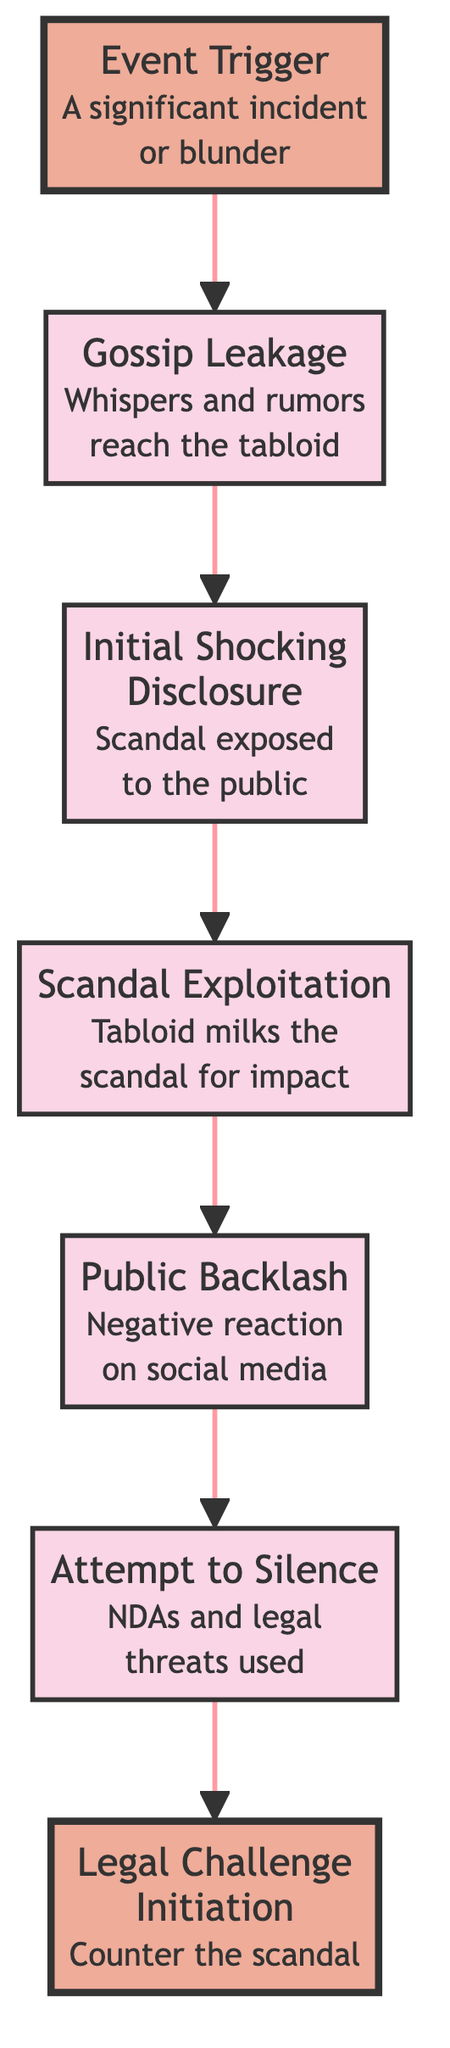What is the first step in the scandal lifecycle? The first node in the flowchart is "Event Trigger," which initiates the lifecycle of the scandal by highlighting a significant incident or blunder.
Answer: Event Trigger What happens after Gossip Leakage? From the flowchart, "Gossip Leakage" leads to "Initial Shocking Disclosure," marking the progression in the scandal lifecycle after rumors and whispers reach the tabloid.
Answer: Initial Shocking Disclosure How many total nodes are in the diagram? By counting each labeled element presented in the flowchart, there are 7 distinct nodes representing stages in the scandal lifecycle.
Answer: 7 What node follows Public Backlash? According to the flow of the diagram, "Public Backlash" is directly followed by "Attempt to Silence," showing the reaction from the scandalized party.
Answer: Attempt to Silence What initiates the legal challenge in this process? The diagram indicates that "Attempt to Silence" initiates a "Legal Challenge," which represents the mechanism employed by the scandalized party to counter the unfolding scandal.
Answer: Attempt to Silence Which node marks the scandal's public exposure? The node "Initial Shocking Disclosure" refers to the moment when the scandal is publicly exposed, bringing the shocking news to the audience.
Answer: Initial Shocking Disclosure Which two nodes represent legal actions? The nodes that involve legal actions are "Attempt to Silence" and "Legal Challenge Initiation," where efforts to quiet the scandal lead to the initiation of legal processes.
Answer: Attempt to Silence, Legal Challenge Initiation What triggers the entire lifecycle of the scandal? The flowchart indicates that "Event Trigger" is the starting point that initiates the entire lifecycle, representing the specific incident that sparks the scandal.
Answer: Event Trigger What is the result of Scandal Exploitation? After "Scandal Exploitation," the flowchart shows it leads to "Public Backlash," indicating that the tabloid's exploitation of the scandal generates a negative public reaction.
Answer: Public Backlash 